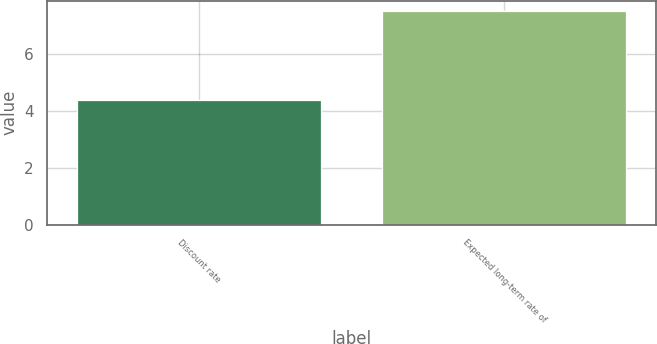<chart> <loc_0><loc_0><loc_500><loc_500><bar_chart><fcel>Discount rate<fcel>Expected long-term rate of<nl><fcel>4.38<fcel>7.5<nl></chart> 